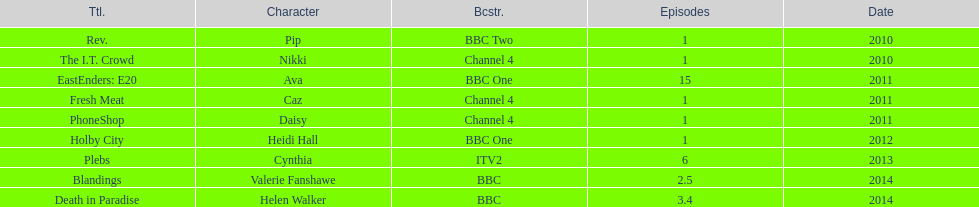What is the total number of shows sophie colguhoun appeared in? 9. 